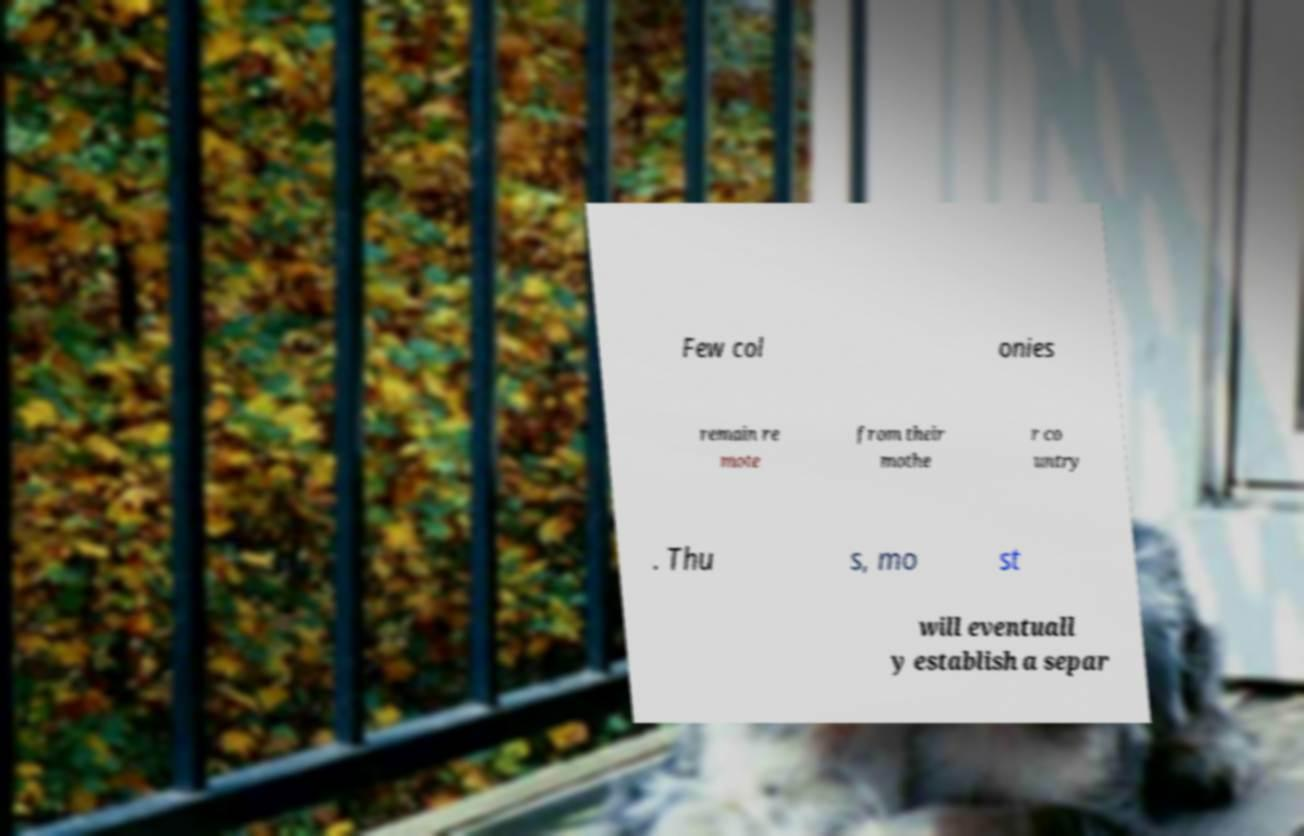Can you accurately transcribe the text from the provided image for me? Few col onies remain re mote from their mothe r co untry . Thu s, mo st will eventuall y establish a separ 